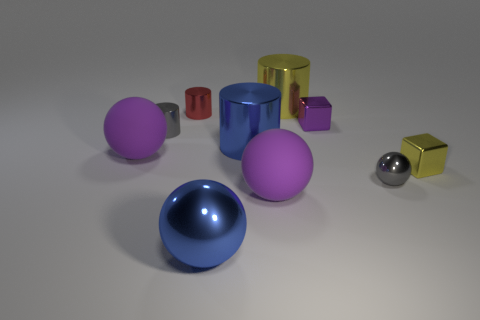There is a gray cylinder that is made of the same material as the small purple thing; what size is it?
Provide a short and direct response. Small. The block that is to the left of the yellow metal thing that is in front of the large yellow metal cylinder is what color?
Your answer should be compact. Purple. What number of yellow cylinders have the same material as the red cylinder?
Ensure brevity in your answer.  1. How many shiny things are small purple things or big blue cylinders?
Make the answer very short. 2. Are there any large purple spheres that have the same material as the small yellow cube?
Ensure brevity in your answer.  No. What shape is the big blue object that is in front of the yellow shiny object that is in front of the small cube on the left side of the yellow metallic block?
Keep it short and to the point. Sphere. There is a purple metal thing; does it have the same size as the yellow object behind the tiny purple shiny object?
Keep it short and to the point. No. What is the shape of the small object that is right of the small red cylinder and on the left side of the small shiny sphere?
Your answer should be compact. Cube. What number of tiny objects are either yellow metallic cylinders or spheres?
Make the answer very short. 1. Is the number of purple cubes in front of the blue shiny ball the same as the number of yellow shiny blocks behind the small gray cylinder?
Offer a terse response. Yes. 